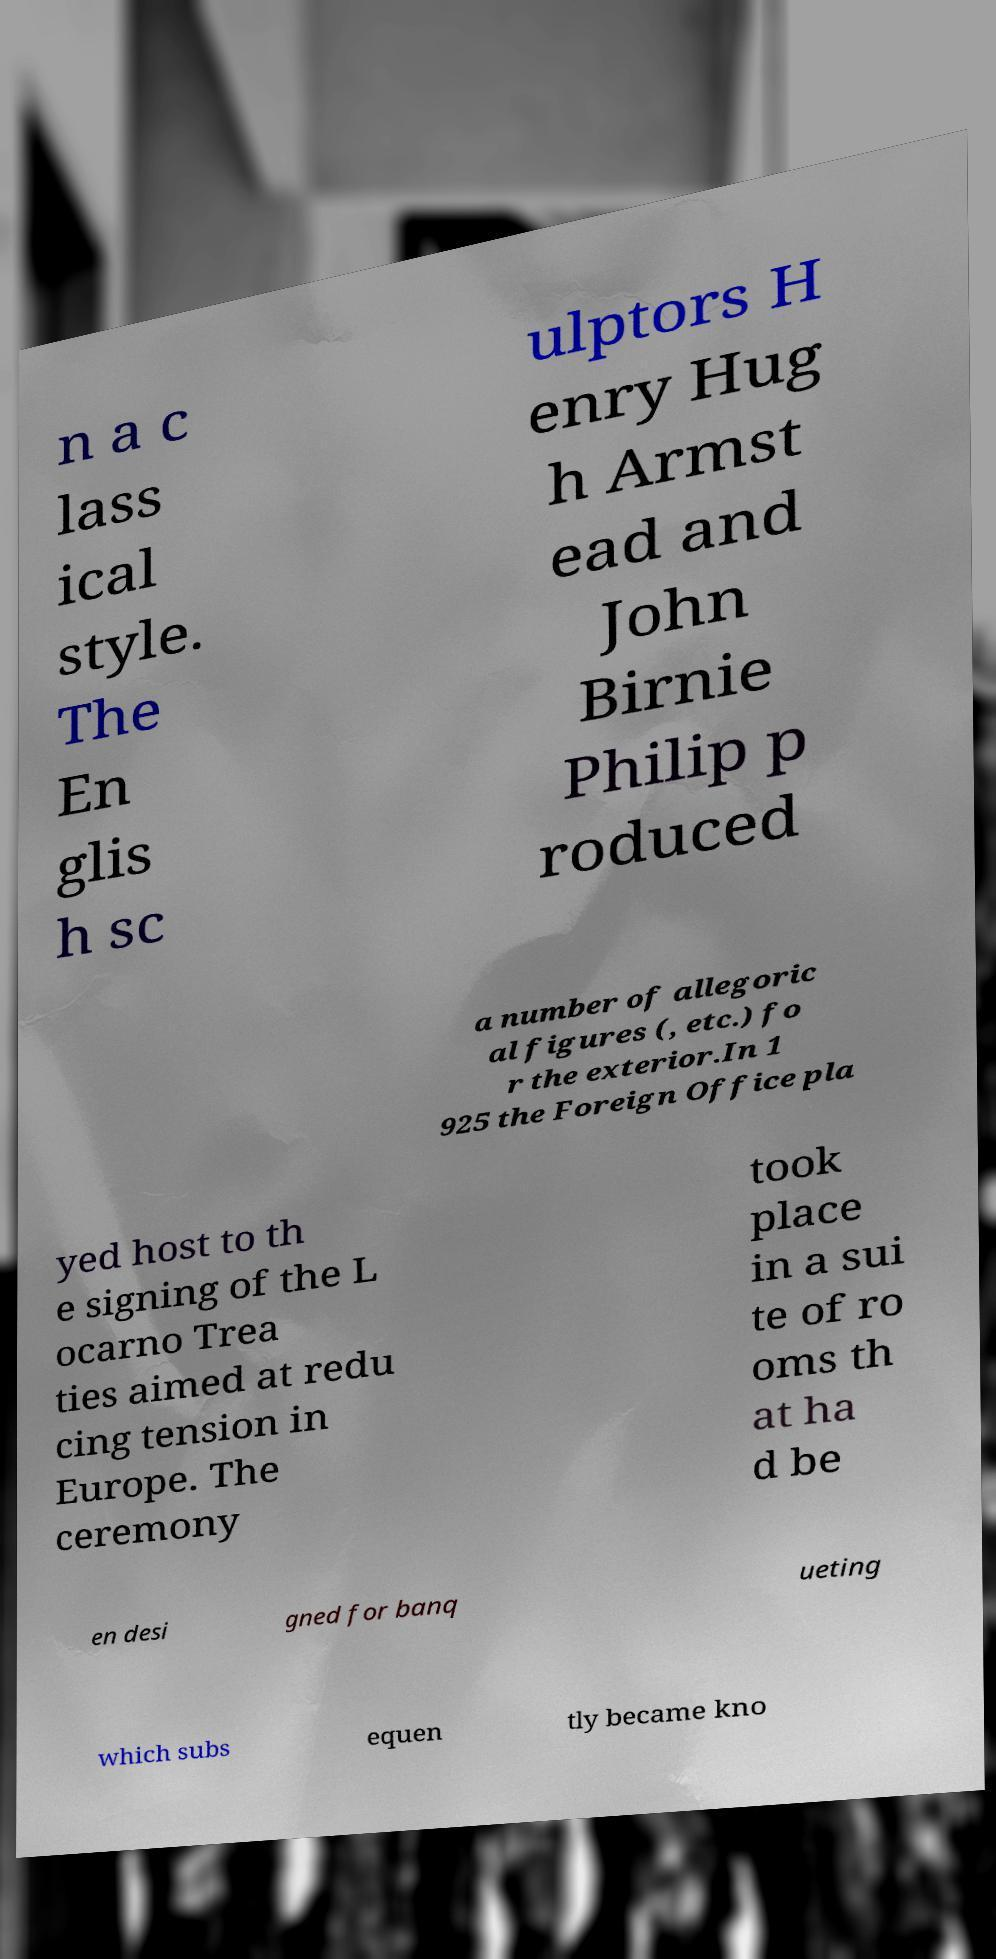I need the written content from this picture converted into text. Can you do that? n a c lass ical style. The En glis h sc ulptors H enry Hug h Armst ead and John Birnie Philip p roduced a number of allegoric al figures (, etc.) fo r the exterior.In 1 925 the Foreign Office pla yed host to th e signing of the L ocarno Trea ties aimed at redu cing tension in Europe. The ceremony took place in a sui te of ro oms th at ha d be en desi gned for banq ueting which subs equen tly became kno 